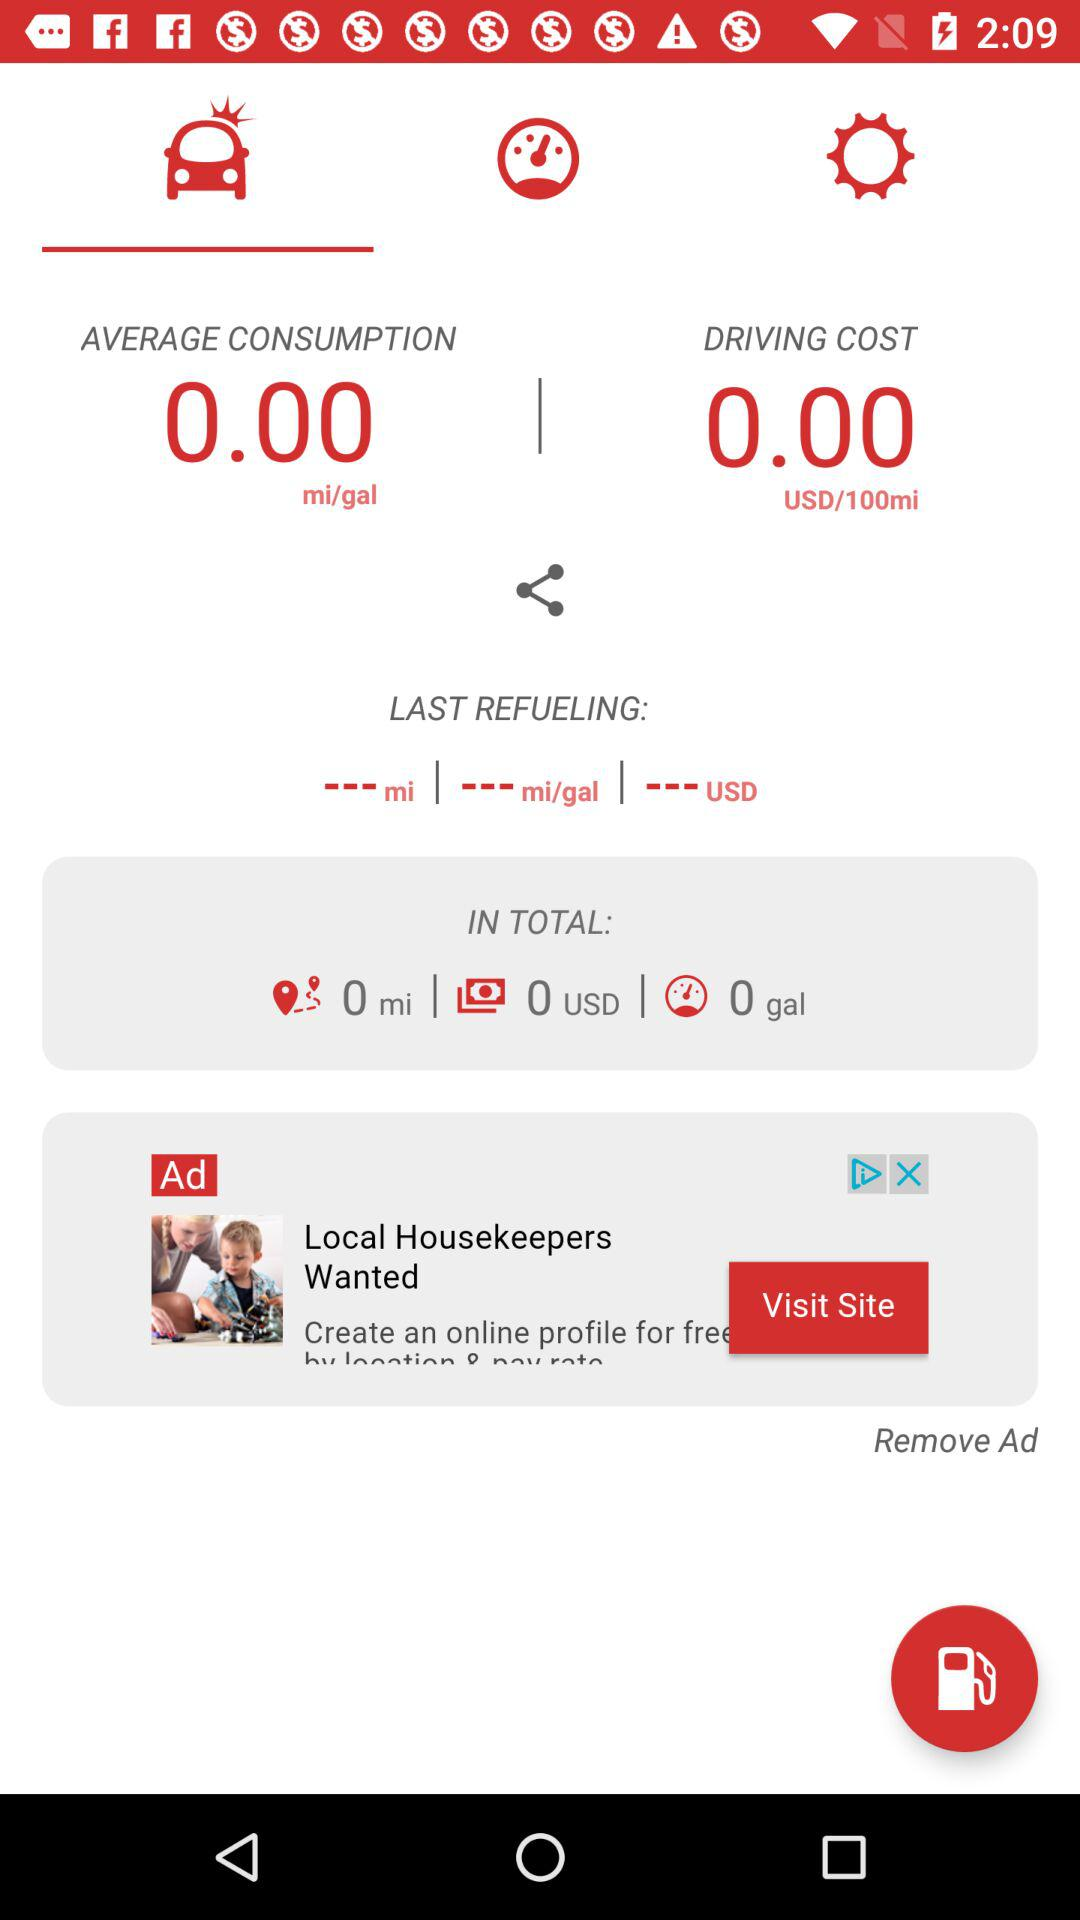How many gallons of gas did I use in total?
Answer the question using a single word or phrase. 0 